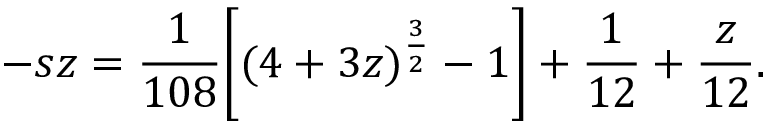<formula> <loc_0><loc_0><loc_500><loc_500>- s z = \frac { 1 } { 1 0 8 } \left [ ( 4 + 3 z ) ^ { \frac { 3 } { 2 } } - 1 \right ] + \frac { 1 } { 1 2 } + \frac { z } { 1 2 } .</formula> 